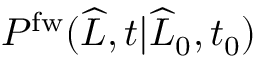<formula> <loc_0><loc_0><loc_500><loc_500>P ^ { f w } ( \widehat { L } , t | \widehat { L } _ { 0 } , t _ { 0 } )</formula> 